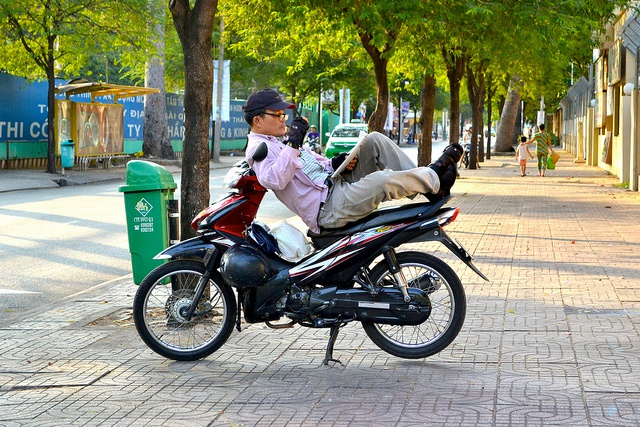Describe the objects in this image and their specific colors. I can see motorcycle in green, black, lightgray, darkgray, and gray tones, people in green, darkgray, black, gray, and lavender tones, handbag in green, lightblue, and darkgray tones, car in green, white, lightblue, and teal tones, and bench in green, gray, black, darkgreen, and darkgray tones in this image. 